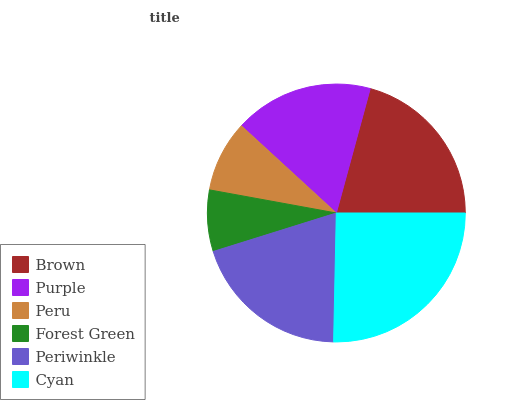Is Forest Green the minimum?
Answer yes or no. Yes. Is Cyan the maximum?
Answer yes or no. Yes. Is Purple the minimum?
Answer yes or no. No. Is Purple the maximum?
Answer yes or no. No. Is Brown greater than Purple?
Answer yes or no. Yes. Is Purple less than Brown?
Answer yes or no. Yes. Is Purple greater than Brown?
Answer yes or no. No. Is Brown less than Purple?
Answer yes or no. No. Is Periwinkle the high median?
Answer yes or no. Yes. Is Purple the low median?
Answer yes or no. Yes. Is Purple the high median?
Answer yes or no. No. Is Forest Green the low median?
Answer yes or no. No. 